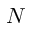Convert formula to latex. <formula><loc_0><loc_0><loc_500><loc_500>N</formula> 